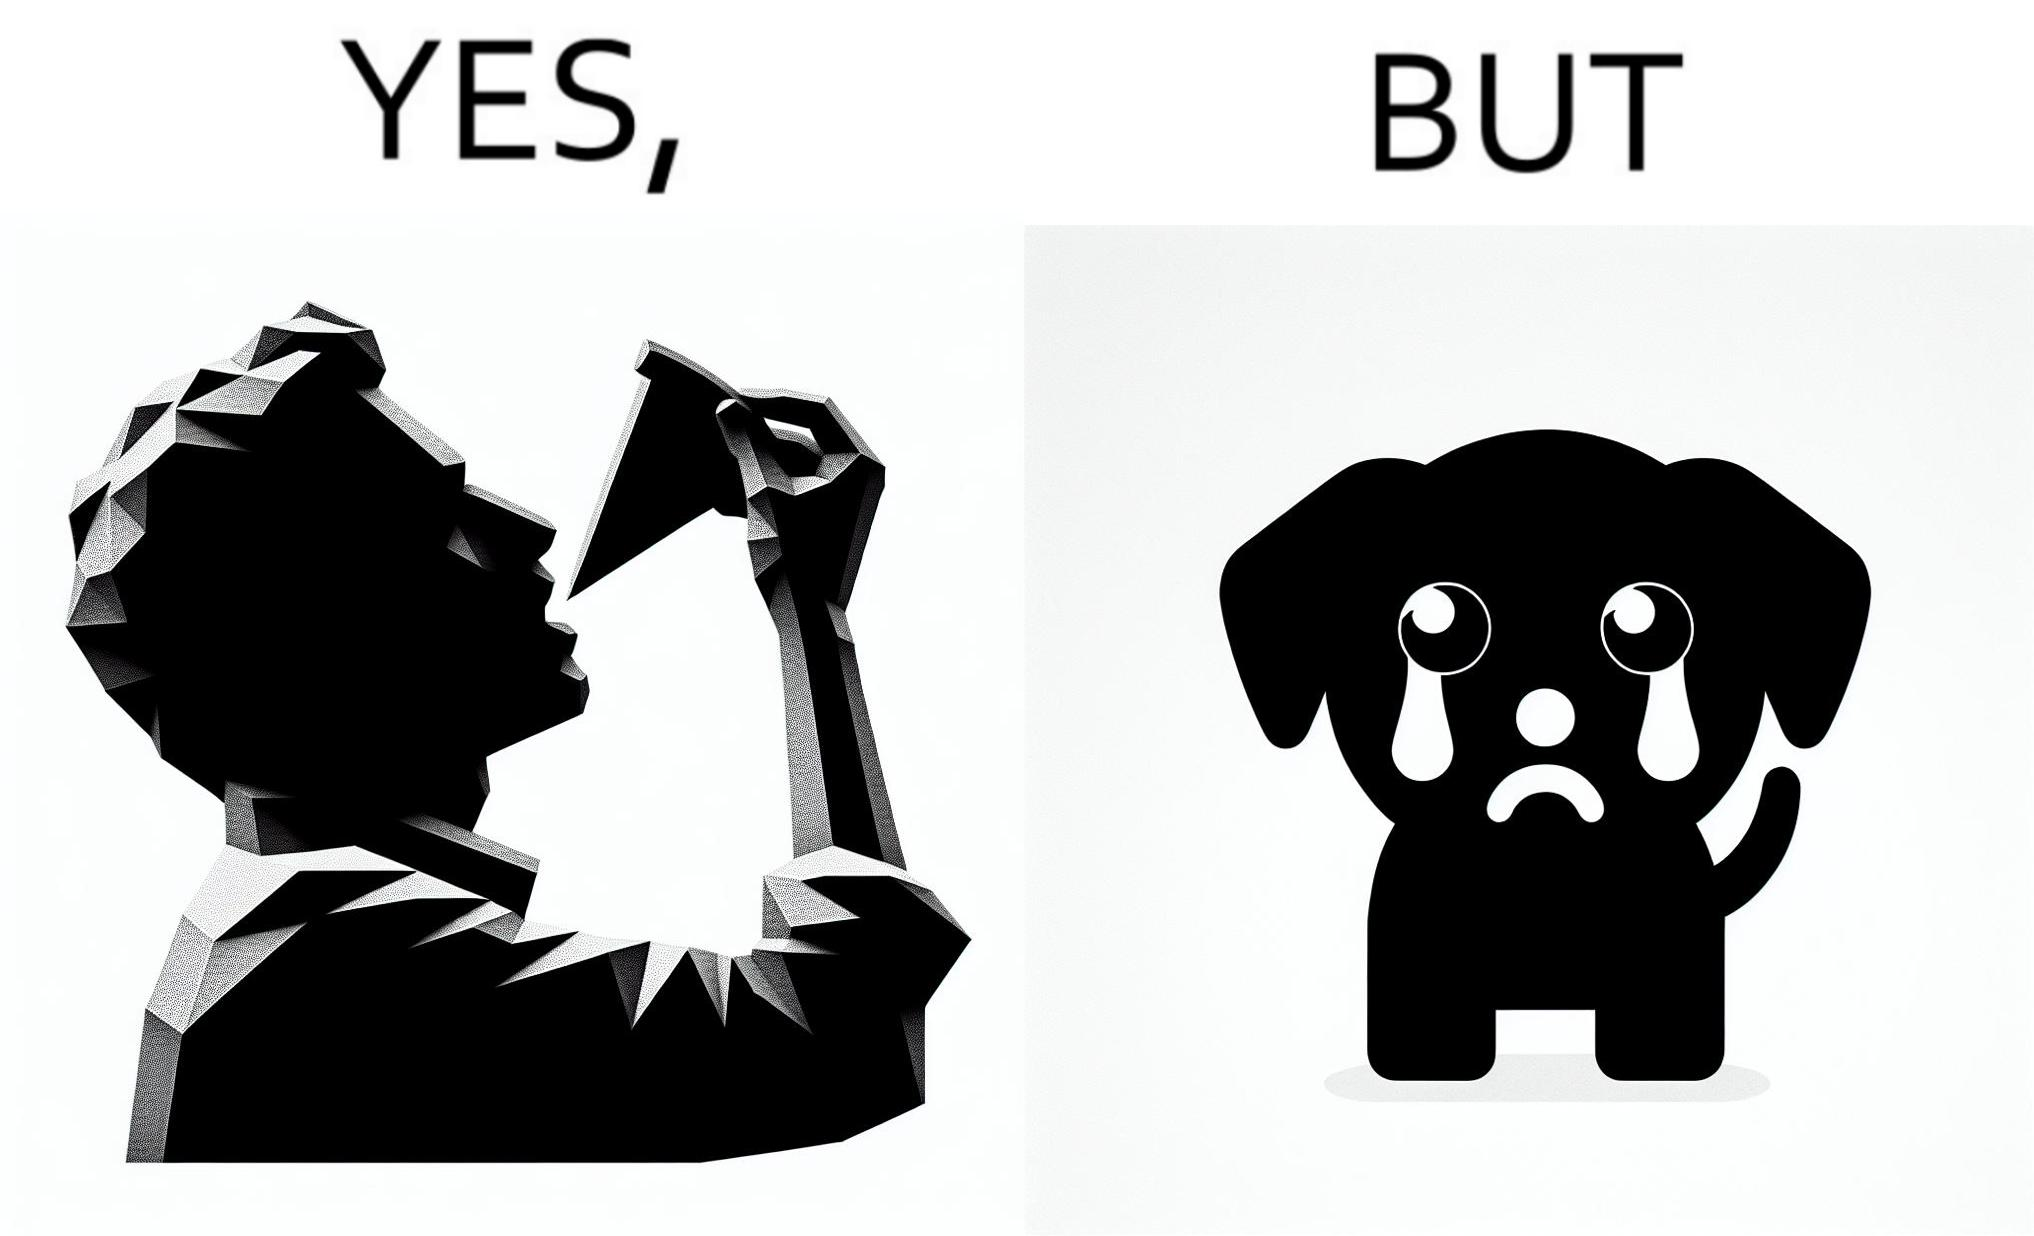Is there satirical content in this image? Yes, this image is satirical. 